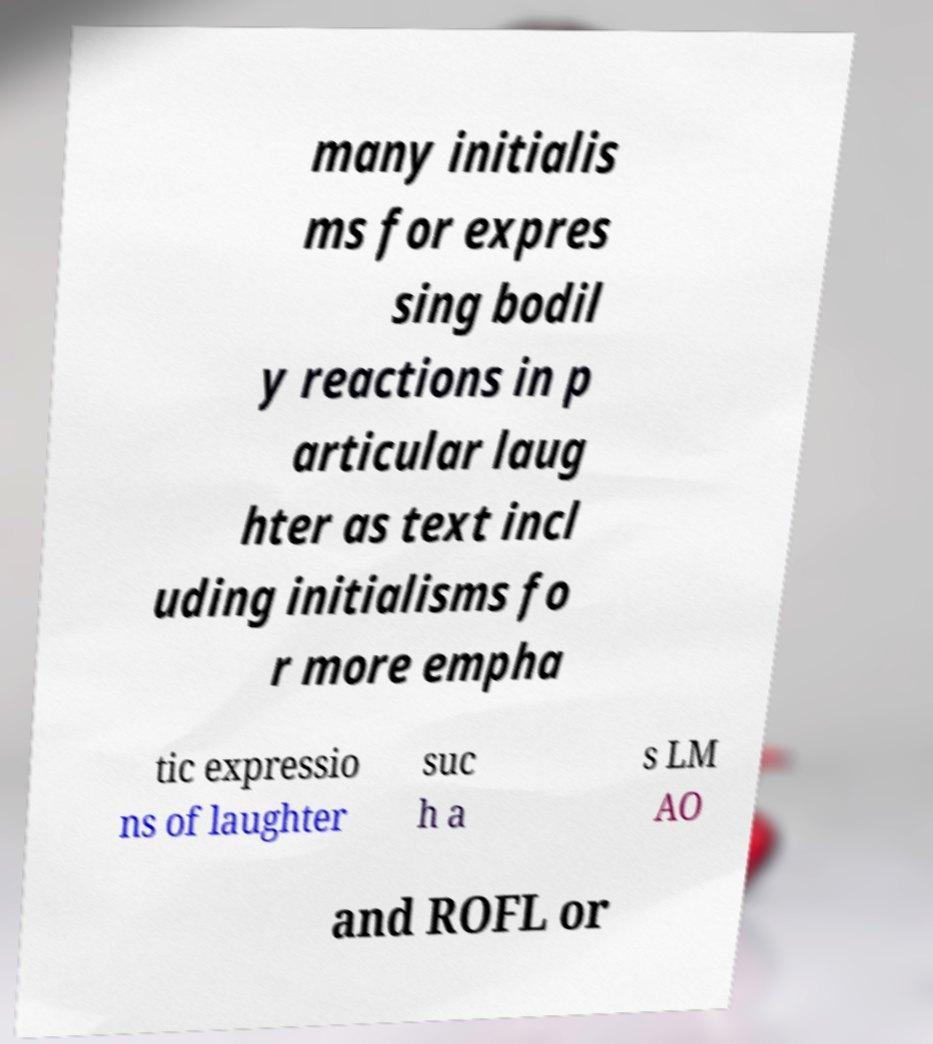For documentation purposes, I need the text within this image transcribed. Could you provide that? many initialis ms for expres sing bodil y reactions in p articular laug hter as text incl uding initialisms fo r more empha tic expressio ns of laughter suc h a s LM AO and ROFL or 